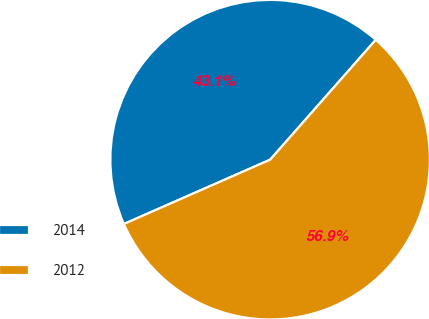<chart> <loc_0><loc_0><loc_500><loc_500><pie_chart><fcel>2014<fcel>2012<nl><fcel>43.09%<fcel>56.91%<nl></chart> 